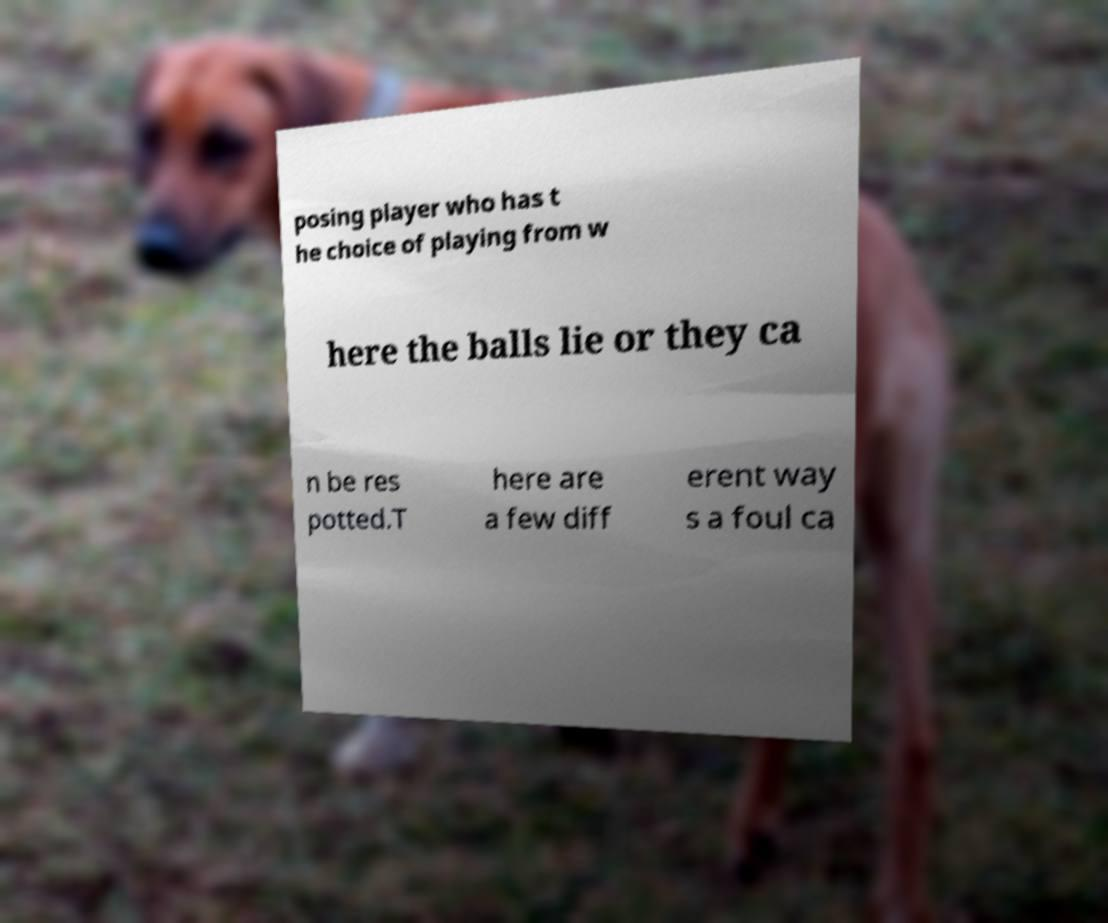For documentation purposes, I need the text within this image transcribed. Could you provide that? posing player who has t he choice of playing from w here the balls lie or they ca n be res potted.T here are a few diff erent way s a foul ca 